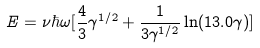Convert formula to latex. <formula><loc_0><loc_0><loc_500><loc_500>E = \nu \hbar { \omega } [ \frac { 4 } { 3 } \gamma ^ { 1 / 2 } + \frac { 1 } { 3 \gamma ^ { 1 / 2 } } \ln ( 1 3 . 0 \gamma ) ]</formula> 